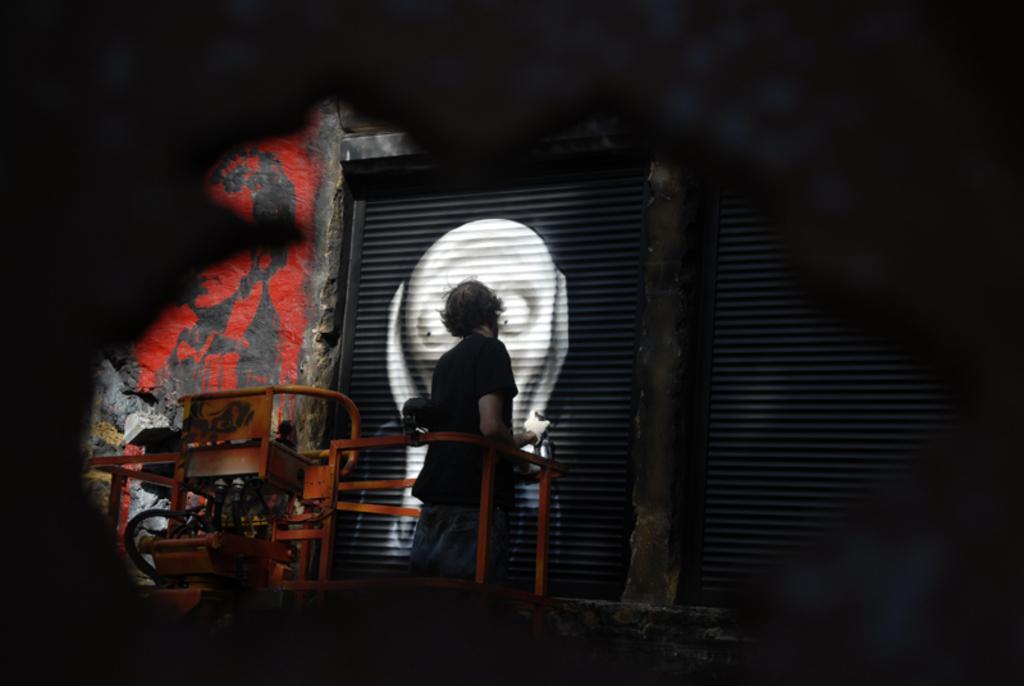In one or two sentences, can you explain what this image depicts? This image is taken in the dark where we can see this person wearing black T-shirt is standing on a lifter machine and holding a paint bottle and painting on the the shutter. 